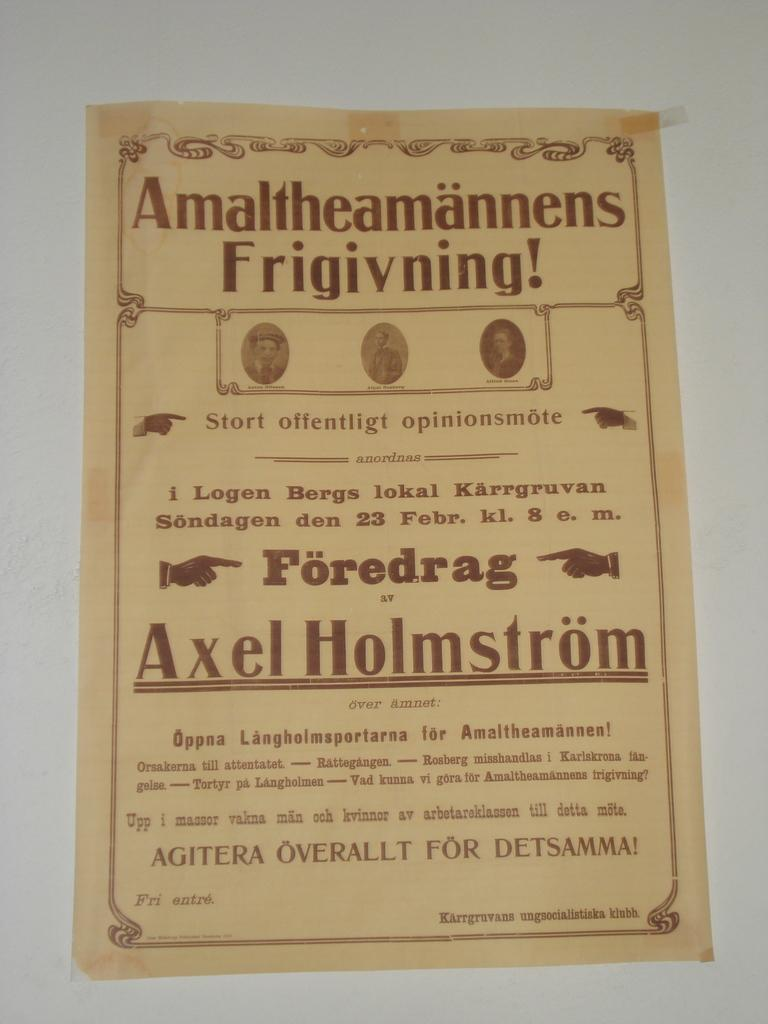<image>
Relay a brief, clear account of the picture shown. A paper with Amaltheamannens Frigivning on it in brown writing. 